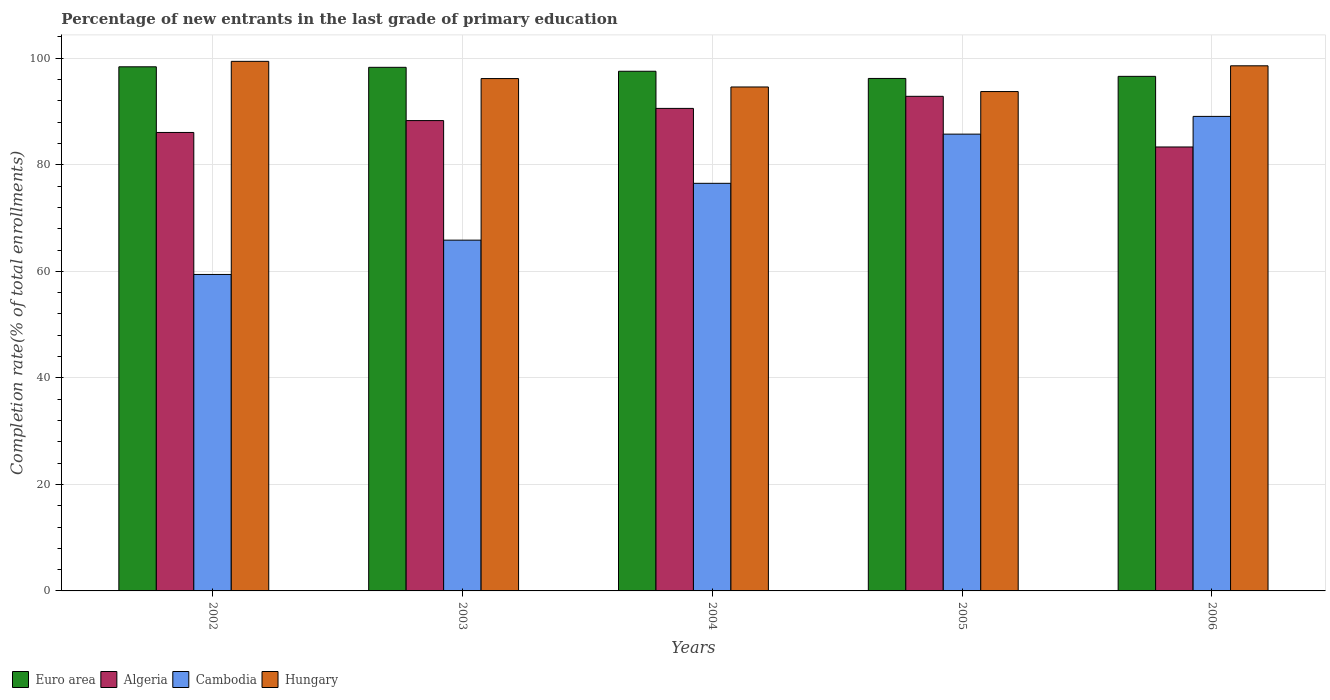How many groups of bars are there?
Ensure brevity in your answer.  5. Are the number of bars per tick equal to the number of legend labels?
Keep it short and to the point. Yes. Are the number of bars on each tick of the X-axis equal?
Your answer should be very brief. Yes. How many bars are there on the 4th tick from the right?
Provide a short and direct response. 4. In how many cases, is the number of bars for a given year not equal to the number of legend labels?
Your answer should be compact. 0. What is the percentage of new entrants in Hungary in 2002?
Provide a short and direct response. 99.42. Across all years, what is the maximum percentage of new entrants in Hungary?
Keep it short and to the point. 99.42. Across all years, what is the minimum percentage of new entrants in Algeria?
Your answer should be compact. 83.35. In which year was the percentage of new entrants in Cambodia maximum?
Your response must be concise. 2006. In which year was the percentage of new entrants in Hungary minimum?
Provide a short and direct response. 2005. What is the total percentage of new entrants in Algeria in the graph?
Keep it short and to the point. 441.18. What is the difference between the percentage of new entrants in Euro area in 2003 and that in 2004?
Offer a very short reply. 0.74. What is the difference between the percentage of new entrants in Cambodia in 2006 and the percentage of new entrants in Algeria in 2002?
Ensure brevity in your answer.  3.01. What is the average percentage of new entrants in Algeria per year?
Keep it short and to the point. 88.24. In the year 2006, what is the difference between the percentage of new entrants in Euro area and percentage of new entrants in Hungary?
Your answer should be compact. -1.98. What is the ratio of the percentage of new entrants in Cambodia in 2002 to that in 2006?
Provide a succinct answer. 0.67. Is the percentage of new entrants in Cambodia in 2003 less than that in 2005?
Keep it short and to the point. Yes. What is the difference between the highest and the second highest percentage of new entrants in Cambodia?
Your answer should be compact. 3.33. What is the difference between the highest and the lowest percentage of new entrants in Hungary?
Offer a very short reply. 5.67. Is it the case that in every year, the sum of the percentage of new entrants in Euro area and percentage of new entrants in Cambodia is greater than the sum of percentage of new entrants in Hungary and percentage of new entrants in Algeria?
Your response must be concise. No. What does the 1st bar from the left in 2005 represents?
Make the answer very short. Euro area. What does the 3rd bar from the right in 2006 represents?
Offer a terse response. Algeria. Are all the bars in the graph horizontal?
Provide a succinct answer. No. How many years are there in the graph?
Your answer should be very brief. 5. What is the difference between two consecutive major ticks on the Y-axis?
Your response must be concise. 20. Are the values on the major ticks of Y-axis written in scientific E-notation?
Your answer should be compact. No. Does the graph contain grids?
Offer a very short reply. Yes. What is the title of the graph?
Provide a short and direct response. Percentage of new entrants in the last grade of primary education. What is the label or title of the X-axis?
Your answer should be compact. Years. What is the label or title of the Y-axis?
Offer a very short reply. Completion rate(% of total enrollments). What is the Completion rate(% of total enrollments) of Euro area in 2002?
Your answer should be compact. 98.4. What is the Completion rate(% of total enrollments) of Algeria in 2002?
Offer a terse response. 86.07. What is the Completion rate(% of total enrollments) of Cambodia in 2002?
Your response must be concise. 59.41. What is the Completion rate(% of total enrollments) in Hungary in 2002?
Provide a short and direct response. 99.42. What is the Completion rate(% of total enrollments) of Euro area in 2003?
Ensure brevity in your answer.  98.3. What is the Completion rate(% of total enrollments) of Algeria in 2003?
Ensure brevity in your answer.  88.3. What is the Completion rate(% of total enrollments) in Cambodia in 2003?
Your answer should be compact. 65.86. What is the Completion rate(% of total enrollments) of Hungary in 2003?
Ensure brevity in your answer.  96.19. What is the Completion rate(% of total enrollments) in Euro area in 2004?
Your answer should be compact. 97.56. What is the Completion rate(% of total enrollments) of Algeria in 2004?
Give a very brief answer. 90.59. What is the Completion rate(% of total enrollments) in Cambodia in 2004?
Provide a succinct answer. 76.53. What is the Completion rate(% of total enrollments) in Hungary in 2004?
Keep it short and to the point. 94.61. What is the Completion rate(% of total enrollments) in Euro area in 2005?
Offer a terse response. 96.21. What is the Completion rate(% of total enrollments) of Algeria in 2005?
Provide a succinct answer. 92.86. What is the Completion rate(% of total enrollments) of Cambodia in 2005?
Provide a succinct answer. 85.76. What is the Completion rate(% of total enrollments) of Hungary in 2005?
Make the answer very short. 93.75. What is the Completion rate(% of total enrollments) of Euro area in 2006?
Your answer should be compact. 96.61. What is the Completion rate(% of total enrollments) in Algeria in 2006?
Offer a very short reply. 83.35. What is the Completion rate(% of total enrollments) in Cambodia in 2006?
Your answer should be very brief. 89.09. What is the Completion rate(% of total enrollments) in Hungary in 2006?
Provide a short and direct response. 98.59. Across all years, what is the maximum Completion rate(% of total enrollments) in Euro area?
Your answer should be compact. 98.4. Across all years, what is the maximum Completion rate(% of total enrollments) of Algeria?
Offer a very short reply. 92.86. Across all years, what is the maximum Completion rate(% of total enrollments) of Cambodia?
Give a very brief answer. 89.09. Across all years, what is the maximum Completion rate(% of total enrollments) in Hungary?
Provide a succinct answer. 99.42. Across all years, what is the minimum Completion rate(% of total enrollments) of Euro area?
Provide a succinct answer. 96.21. Across all years, what is the minimum Completion rate(% of total enrollments) of Algeria?
Give a very brief answer. 83.35. Across all years, what is the minimum Completion rate(% of total enrollments) in Cambodia?
Your answer should be compact. 59.41. Across all years, what is the minimum Completion rate(% of total enrollments) of Hungary?
Offer a terse response. 93.75. What is the total Completion rate(% of total enrollments) of Euro area in the graph?
Provide a succinct answer. 487.09. What is the total Completion rate(% of total enrollments) in Algeria in the graph?
Provide a succinct answer. 441.18. What is the total Completion rate(% of total enrollments) of Cambodia in the graph?
Make the answer very short. 376.64. What is the total Completion rate(% of total enrollments) in Hungary in the graph?
Your answer should be compact. 482.57. What is the difference between the Completion rate(% of total enrollments) in Euro area in 2002 and that in 2003?
Your response must be concise. 0.1. What is the difference between the Completion rate(% of total enrollments) of Algeria in 2002 and that in 2003?
Your answer should be compact. -2.23. What is the difference between the Completion rate(% of total enrollments) of Cambodia in 2002 and that in 2003?
Your response must be concise. -6.44. What is the difference between the Completion rate(% of total enrollments) of Hungary in 2002 and that in 2003?
Give a very brief answer. 3.23. What is the difference between the Completion rate(% of total enrollments) in Euro area in 2002 and that in 2004?
Ensure brevity in your answer.  0.84. What is the difference between the Completion rate(% of total enrollments) of Algeria in 2002 and that in 2004?
Ensure brevity in your answer.  -4.52. What is the difference between the Completion rate(% of total enrollments) of Cambodia in 2002 and that in 2004?
Your response must be concise. -17.11. What is the difference between the Completion rate(% of total enrollments) of Hungary in 2002 and that in 2004?
Your answer should be very brief. 4.81. What is the difference between the Completion rate(% of total enrollments) of Euro area in 2002 and that in 2005?
Your answer should be compact. 2.19. What is the difference between the Completion rate(% of total enrollments) in Algeria in 2002 and that in 2005?
Your response must be concise. -6.78. What is the difference between the Completion rate(% of total enrollments) of Cambodia in 2002 and that in 2005?
Provide a short and direct response. -26.35. What is the difference between the Completion rate(% of total enrollments) of Hungary in 2002 and that in 2005?
Offer a very short reply. 5.67. What is the difference between the Completion rate(% of total enrollments) of Euro area in 2002 and that in 2006?
Provide a succinct answer. 1.79. What is the difference between the Completion rate(% of total enrollments) of Algeria in 2002 and that in 2006?
Ensure brevity in your answer.  2.73. What is the difference between the Completion rate(% of total enrollments) of Cambodia in 2002 and that in 2006?
Your answer should be compact. -29.68. What is the difference between the Completion rate(% of total enrollments) of Hungary in 2002 and that in 2006?
Your response must be concise. 0.84. What is the difference between the Completion rate(% of total enrollments) of Euro area in 2003 and that in 2004?
Ensure brevity in your answer.  0.74. What is the difference between the Completion rate(% of total enrollments) of Algeria in 2003 and that in 2004?
Ensure brevity in your answer.  -2.29. What is the difference between the Completion rate(% of total enrollments) in Cambodia in 2003 and that in 2004?
Keep it short and to the point. -10.67. What is the difference between the Completion rate(% of total enrollments) of Hungary in 2003 and that in 2004?
Make the answer very short. 1.58. What is the difference between the Completion rate(% of total enrollments) of Euro area in 2003 and that in 2005?
Provide a succinct answer. 2.09. What is the difference between the Completion rate(% of total enrollments) in Algeria in 2003 and that in 2005?
Ensure brevity in your answer.  -4.55. What is the difference between the Completion rate(% of total enrollments) of Cambodia in 2003 and that in 2005?
Offer a very short reply. -19.9. What is the difference between the Completion rate(% of total enrollments) of Hungary in 2003 and that in 2005?
Offer a very short reply. 2.44. What is the difference between the Completion rate(% of total enrollments) in Euro area in 2003 and that in 2006?
Provide a succinct answer. 1.69. What is the difference between the Completion rate(% of total enrollments) in Algeria in 2003 and that in 2006?
Provide a succinct answer. 4.96. What is the difference between the Completion rate(% of total enrollments) in Cambodia in 2003 and that in 2006?
Provide a succinct answer. -23.23. What is the difference between the Completion rate(% of total enrollments) of Hungary in 2003 and that in 2006?
Ensure brevity in your answer.  -2.4. What is the difference between the Completion rate(% of total enrollments) in Euro area in 2004 and that in 2005?
Provide a succinct answer. 1.35. What is the difference between the Completion rate(% of total enrollments) of Algeria in 2004 and that in 2005?
Offer a terse response. -2.27. What is the difference between the Completion rate(% of total enrollments) in Cambodia in 2004 and that in 2005?
Give a very brief answer. -9.23. What is the difference between the Completion rate(% of total enrollments) of Hungary in 2004 and that in 2005?
Your answer should be compact. 0.86. What is the difference between the Completion rate(% of total enrollments) in Euro area in 2004 and that in 2006?
Your answer should be compact. 0.96. What is the difference between the Completion rate(% of total enrollments) of Algeria in 2004 and that in 2006?
Your answer should be compact. 7.24. What is the difference between the Completion rate(% of total enrollments) of Cambodia in 2004 and that in 2006?
Provide a short and direct response. -12.56. What is the difference between the Completion rate(% of total enrollments) in Hungary in 2004 and that in 2006?
Ensure brevity in your answer.  -3.98. What is the difference between the Completion rate(% of total enrollments) of Euro area in 2005 and that in 2006?
Provide a short and direct response. -0.39. What is the difference between the Completion rate(% of total enrollments) of Algeria in 2005 and that in 2006?
Make the answer very short. 9.51. What is the difference between the Completion rate(% of total enrollments) of Cambodia in 2005 and that in 2006?
Your answer should be compact. -3.33. What is the difference between the Completion rate(% of total enrollments) in Hungary in 2005 and that in 2006?
Offer a very short reply. -4.83. What is the difference between the Completion rate(% of total enrollments) of Euro area in 2002 and the Completion rate(% of total enrollments) of Algeria in 2003?
Ensure brevity in your answer.  10.1. What is the difference between the Completion rate(% of total enrollments) in Euro area in 2002 and the Completion rate(% of total enrollments) in Cambodia in 2003?
Offer a terse response. 32.55. What is the difference between the Completion rate(% of total enrollments) in Euro area in 2002 and the Completion rate(% of total enrollments) in Hungary in 2003?
Make the answer very short. 2.21. What is the difference between the Completion rate(% of total enrollments) of Algeria in 2002 and the Completion rate(% of total enrollments) of Cambodia in 2003?
Make the answer very short. 20.22. What is the difference between the Completion rate(% of total enrollments) of Algeria in 2002 and the Completion rate(% of total enrollments) of Hungary in 2003?
Your answer should be compact. -10.12. What is the difference between the Completion rate(% of total enrollments) in Cambodia in 2002 and the Completion rate(% of total enrollments) in Hungary in 2003?
Make the answer very short. -36.78. What is the difference between the Completion rate(% of total enrollments) in Euro area in 2002 and the Completion rate(% of total enrollments) in Algeria in 2004?
Your response must be concise. 7.81. What is the difference between the Completion rate(% of total enrollments) of Euro area in 2002 and the Completion rate(% of total enrollments) of Cambodia in 2004?
Give a very brief answer. 21.88. What is the difference between the Completion rate(% of total enrollments) of Euro area in 2002 and the Completion rate(% of total enrollments) of Hungary in 2004?
Offer a very short reply. 3.79. What is the difference between the Completion rate(% of total enrollments) in Algeria in 2002 and the Completion rate(% of total enrollments) in Cambodia in 2004?
Provide a short and direct response. 9.55. What is the difference between the Completion rate(% of total enrollments) of Algeria in 2002 and the Completion rate(% of total enrollments) of Hungary in 2004?
Provide a short and direct response. -8.54. What is the difference between the Completion rate(% of total enrollments) of Cambodia in 2002 and the Completion rate(% of total enrollments) of Hungary in 2004?
Your answer should be very brief. -35.2. What is the difference between the Completion rate(% of total enrollments) of Euro area in 2002 and the Completion rate(% of total enrollments) of Algeria in 2005?
Offer a terse response. 5.54. What is the difference between the Completion rate(% of total enrollments) in Euro area in 2002 and the Completion rate(% of total enrollments) in Cambodia in 2005?
Ensure brevity in your answer.  12.64. What is the difference between the Completion rate(% of total enrollments) of Euro area in 2002 and the Completion rate(% of total enrollments) of Hungary in 2005?
Ensure brevity in your answer.  4.65. What is the difference between the Completion rate(% of total enrollments) of Algeria in 2002 and the Completion rate(% of total enrollments) of Cambodia in 2005?
Keep it short and to the point. 0.32. What is the difference between the Completion rate(% of total enrollments) of Algeria in 2002 and the Completion rate(% of total enrollments) of Hungary in 2005?
Ensure brevity in your answer.  -7.68. What is the difference between the Completion rate(% of total enrollments) in Cambodia in 2002 and the Completion rate(% of total enrollments) in Hungary in 2005?
Give a very brief answer. -34.34. What is the difference between the Completion rate(% of total enrollments) of Euro area in 2002 and the Completion rate(% of total enrollments) of Algeria in 2006?
Your response must be concise. 15.05. What is the difference between the Completion rate(% of total enrollments) of Euro area in 2002 and the Completion rate(% of total enrollments) of Cambodia in 2006?
Offer a very short reply. 9.31. What is the difference between the Completion rate(% of total enrollments) of Euro area in 2002 and the Completion rate(% of total enrollments) of Hungary in 2006?
Offer a very short reply. -0.19. What is the difference between the Completion rate(% of total enrollments) of Algeria in 2002 and the Completion rate(% of total enrollments) of Cambodia in 2006?
Your response must be concise. -3.01. What is the difference between the Completion rate(% of total enrollments) of Algeria in 2002 and the Completion rate(% of total enrollments) of Hungary in 2006?
Give a very brief answer. -12.51. What is the difference between the Completion rate(% of total enrollments) of Cambodia in 2002 and the Completion rate(% of total enrollments) of Hungary in 2006?
Offer a terse response. -39.18. What is the difference between the Completion rate(% of total enrollments) in Euro area in 2003 and the Completion rate(% of total enrollments) in Algeria in 2004?
Your response must be concise. 7.71. What is the difference between the Completion rate(% of total enrollments) in Euro area in 2003 and the Completion rate(% of total enrollments) in Cambodia in 2004?
Your answer should be compact. 21.78. What is the difference between the Completion rate(% of total enrollments) in Euro area in 2003 and the Completion rate(% of total enrollments) in Hungary in 2004?
Offer a terse response. 3.69. What is the difference between the Completion rate(% of total enrollments) of Algeria in 2003 and the Completion rate(% of total enrollments) of Cambodia in 2004?
Offer a terse response. 11.78. What is the difference between the Completion rate(% of total enrollments) in Algeria in 2003 and the Completion rate(% of total enrollments) in Hungary in 2004?
Offer a terse response. -6.31. What is the difference between the Completion rate(% of total enrollments) of Cambodia in 2003 and the Completion rate(% of total enrollments) of Hungary in 2004?
Offer a terse response. -28.76. What is the difference between the Completion rate(% of total enrollments) of Euro area in 2003 and the Completion rate(% of total enrollments) of Algeria in 2005?
Make the answer very short. 5.45. What is the difference between the Completion rate(% of total enrollments) in Euro area in 2003 and the Completion rate(% of total enrollments) in Cambodia in 2005?
Your answer should be compact. 12.54. What is the difference between the Completion rate(% of total enrollments) in Euro area in 2003 and the Completion rate(% of total enrollments) in Hungary in 2005?
Your response must be concise. 4.55. What is the difference between the Completion rate(% of total enrollments) in Algeria in 2003 and the Completion rate(% of total enrollments) in Cambodia in 2005?
Provide a short and direct response. 2.54. What is the difference between the Completion rate(% of total enrollments) in Algeria in 2003 and the Completion rate(% of total enrollments) in Hungary in 2005?
Your response must be concise. -5.45. What is the difference between the Completion rate(% of total enrollments) of Cambodia in 2003 and the Completion rate(% of total enrollments) of Hungary in 2005?
Your answer should be very brief. -27.9. What is the difference between the Completion rate(% of total enrollments) of Euro area in 2003 and the Completion rate(% of total enrollments) of Algeria in 2006?
Your answer should be compact. 14.95. What is the difference between the Completion rate(% of total enrollments) in Euro area in 2003 and the Completion rate(% of total enrollments) in Cambodia in 2006?
Offer a terse response. 9.21. What is the difference between the Completion rate(% of total enrollments) in Euro area in 2003 and the Completion rate(% of total enrollments) in Hungary in 2006?
Your answer should be compact. -0.29. What is the difference between the Completion rate(% of total enrollments) of Algeria in 2003 and the Completion rate(% of total enrollments) of Cambodia in 2006?
Offer a very short reply. -0.79. What is the difference between the Completion rate(% of total enrollments) of Algeria in 2003 and the Completion rate(% of total enrollments) of Hungary in 2006?
Make the answer very short. -10.28. What is the difference between the Completion rate(% of total enrollments) in Cambodia in 2003 and the Completion rate(% of total enrollments) in Hungary in 2006?
Give a very brief answer. -32.73. What is the difference between the Completion rate(% of total enrollments) of Euro area in 2004 and the Completion rate(% of total enrollments) of Algeria in 2005?
Keep it short and to the point. 4.71. What is the difference between the Completion rate(% of total enrollments) in Euro area in 2004 and the Completion rate(% of total enrollments) in Cambodia in 2005?
Your response must be concise. 11.8. What is the difference between the Completion rate(% of total enrollments) of Euro area in 2004 and the Completion rate(% of total enrollments) of Hungary in 2005?
Offer a terse response. 3.81. What is the difference between the Completion rate(% of total enrollments) in Algeria in 2004 and the Completion rate(% of total enrollments) in Cambodia in 2005?
Your answer should be very brief. 4.83. What is the difference between the Completion rate(% of total enrollments) in Algeria in 2004 and the Completion rate(% of total enrollments) in Hungary in 2005?
Your answer should be very brief. -3.16. What is the difference between the Completion rate(% of total enrollments) of Cambodia in 2004 and the Completion rate(% of total enrollments) of Hungary in 2005?
Provide a short and direct response. -17.23. What is the difference between the Completion rate(% of total enrollments) of Euro area in 2004 and the Completion rate(% of total enrollments) of Algeria in 2006?
Ensure brevity in your answer.  14.22. What is the difference between the Completion rate(% of total enrollments) of Euro area in 2004 and the Completion rate(% of total enrollments) of Cambodia in 2006?
Your response must be concise. 8.47. What is the difference between the Completion rate(% of total enrollments) of Euro area in 2004 and the Completion rate(% of total enrollments) of Hungary in 2006?
Keep it short and to the point. -1.02. What is the difference between the Completion rate(% of total enrollments) of Algeria in 2004 and the Completion rate(% of total enrollments) of Cambodia in 2006?
Provide a succinct answer. 1.5. What is the difference between the Completion rate(% of total enrollments) of Algeria in 2004 and the Completion rate(% of total enrollments) of Hungary in 2006?
Offer a very short reply. -8. What is the difference between the Completion rate(% of total enrollments) in Cambodia in 2004 and the Completion rate(% of total enrollments) in Hungary in 2006?
Your response must be concise. -22.06. What is the difference between the Completion rate(% of total enrollments) in Euro area in 2005 and the Completion rate(% of total enrollments) in Algeria in 2006?
Make the answer very short. 12.87. What is the difference between the Completion rate(% of total enrollments) of Euro area in 2005 and the Completion rate(% of total enrollments) of Cambodia in 2006?
Offer a very short reply. 7.13. What is the difference between the Completion rate(% of total enrollments) of Euro area in 2005 and the Completion rate(% of total enrollments) of Hungary in 2006?
Offer a terse response. -2.37. What is the difference between the Completion rate(% of total enrollments) of Algeria in 2005 and the Completion rate(% of total enrollments) of Cambodia in 2006?
Provide a short and direct response. 3.77. What is the difference between the Completion rate(% of total enrollments) in Algeria in 2005 and the Completion rate(% of total enrollments) in Hungary in 2006?
Your response must be concise. -5.73. What is the difference between the Completion rate(% of total enrollments) of Cambodia in 2005 and the Completion rate(% of total enrollments) of Hungary in 2006?
Give a very brief answer. -12.83. What is the average Completion rate(% of total enrollments) in Euro area per year?
Provide a short and direct response. 97.42. What is the average Completion rate(% of total enrollments) of Algeria per year?
Provide a succinct answer. 88.24. What is the average Completion rate(% of total enrollments) of Cambodia per year?
Offer a terse response. 75.33. What is the average Completion rate(% of total enrollments) of Hungary per year?
Give a very brief answer. 96.51. In the year 2002, what is the difference between the Completion rate(% of total enrollments) in Euro area and Completion rate(% of total enrollments) in Algeria?
Ensure brevity in your answer.  12.33. In the year 2002, what is the difference between the Completion rate(% of total enrollments) in Euro area and Completion rate(% of total enrollments) in Cambodia?
Keep it short and to the point. 38.99. In the year 2002, what is the difference between the Completion rate(% of total enrollments) of Euro area and Completion rate(% of total enrollments) of Hungary?
Your answer should be compact. -1.02. In the year 2002, what is the difference between the Completion rate(% of total enrollments) in Algeria and Completion rate(% of total enrollments) in Cambodia?
Provide a succinct answer. 26.66. In the year 2002, what is the difference between the Completion rate(% of total enrollments) in Algeria and Completion rate(% of total enrollments) in Hungary?
Ensure brevity in your answer.  -13.35. In the year 2002, what is the difference between the Completion rate(% of total enrollments) in Cambodia and Completion rate(% of total enrollments) in Hungary?
Ensure brevity in your answer.  -40.01. In the year 2003, what is the difference between the Completion rate(% of total enrollments) of Euro area and Completion rate(% of total enrollments) of Algeria?
Give a very brief answer. 10. In the year 2003, what is the difference between the Completion rate(% of total enrollments) in Euro area and Completion rate(% of total enrollments) in Cambodia?
Your response must be concise. 32.45. In the year 2003, what is the difference between the Completion rate(% of total enrollments) of Euro area and Completion rate(% of total enrollments) of Hungary?
Provide a short and direct response. 2.11. In the year 2003, what is the difference between the Completion rate(% of total enrollments) of Algeria and Completion rate(% of total enrollments) of Cambodia?
Offer a very short reply. 22.45. In the year 2003, what is the difference between the Completion rate(% of total enrollments) in Algeria and Completion rate(% of total enrollments) in Hungary?
Your response must be concise. -7.89. In the year 2003, what is the difference between the Completion rate(% of total enrollments) of Cambodia and Completion rate(% of total enrollments) of Hungary?
Provide a succinct answer. -30.33. In the year 2004, what is the difference between the Completion rate(% of total enrollments) in Euro area and Completion rate(% of total enrollments) in Algeria?
Make the answer very short. 6.97. In the year 2004, what is the difference between the Completion rate(% of total enrollments) in Euro area and Completion rate(% of total enrollments) in Cambodia?
Your answer should be compact. 21.04. In the year 2004, what is the difference between the Completion rate(% of total enrollments) in Euro area and Completion rate(% of total enrollments) in Hungary?
Offer a very short reply. 2.95. In the year 2004, what is the difference between the Completion rate(% of total enrollments) in Algeria and Completion rate(% of total enrollments) in Cambodia?
Provide a short and direct response. 14.06. In the year 2004, what is the difference between the Completion rate(% of total enrollments) in Algeria and Completion rate(% of total enrollments) in Hungary?
Ensure brevity in your answer.  -4.02. In the year 2004, what is the difference between the Completion rate(% of total enrollments) of Cambodia and Completion rate(% of total enrollments) of Hungary?
Provide a short and direct response. -18.09. In the year 2005, what is the difference between the Completion rate(% of total enrollments) of Euro area and Completion rate(% of total enrollments) of Algeria?
Offer a very short reply. 3.36. In the year 2005, what is the difference between the Completion rate(% of total enrollments) of Euro area and Completion rate(% of total enrollments) of Cambodia?
Offer a very short reply. 10.46. In the year 2005, what is the difference between the Completion rate(% of total enrollments) of Euro area and Completion rate(% of total enrollments) of Hungary?
Keep it short and to the point. 2.46. In the year 2005, what is the difference between the Completion rate(% of total enrollments) in Algeria and Completion rate(% of total enrollments) in Cambodia?
Offer a very short reply. 7.1. In the year 2005, what is the difference between the Completion rate(% of total enrollments) of Algeria and Completion rate(% of total enrollments) of Hungary?
Your answer should be very brief. -0.9. In the year 2005, what is the difference between the Completion rate(% of total enrollments) in Cambodia and Completion rate(% of total enrollments) in Hungary?
Offer a terse response. -7.99. In the year 2006, what is the difference between the Completion rate(% of total enrollments) in Euro area and Completion rate(% of total enrollments) in Algeria?
Your answer should be compact. 13.26. In the year 2006, what is the difference between the Completion rate(% of total enrollments) in Euro area and Completion rate(% of total enrollments) in Cambodia?
Provide a short and direct response. 7.52. In the year 2006, what is the difference between the Completion rate(% of total enrollments) of Euro area and Completion rate(% of total enrollments) of Hungary?
Your answer should be compact. -1.98. In the year 2006, what is the difference between the Completion rate(% of total enrollments) of Algeria and Completion rate(% of total enrollments) of Cambodia?
Keep it short and to the point. -5.74. In the year 2006, what is the difference between the Completion rate(% of total enrollments) of Algeria and Completion rate(% of total enrollments) of Hungary?
Offer a very short reply. -15.24. In the year 2006, what is the difference between the Completion rate(% of total enrollments) in Cambodia and Completion rate(% of total enrollments) in Hungary?
Your answer should be very brief. -9.5. What is the ratio of the Completion rate(% of total enrollments) in Algeria in 2002 to that in 2003?
Your answer should be very brief. 0.97. What is the ratio of the Completion rate(% of total enrollments) in Cambodia in 2002 to that in 2003?
Your answer should be compact. 0.9. What is the ratio of the Completion rate(% of total enrollments) in Hungary in 2002 to that in 2003?
Your answer should be compact. 1.03. What is the ratio of the Completion rate(% of total enrollments) of Euro area in 2002 to that in 2004?
Ensure brevity in your answer.  1.01. What is the ratio of the Completion rate(% of total enrollments) in Algeria in 2002 to that in 2004?
Provide a short and direct response. 0.95. What is the ratio of the Completion rate(% of total enrollments) in Cambodia in 2002 to that in 2004?
Make the answer very short. 0.78. What is the ratio of the Completion rate(% of total enrollments) in Hungary in 2002 to that in 2004?
Make the answer very short. 1.05. What is the ratio of the Completion rate(% of total enrollments) of Euro area in 2002 to that in 2005?
Give a very brief answer. 1.02. What is the ratio of the Completion rate(% of total enrollments) of Algeria in 2002 to that in 2005?
Your response must be concise. 0.93. What is the ratio of the Completion rate(% of total enrollments) of Cambodia in 2002 to that in 2005?
Give a very brief answer. 0.69. What is the ratio of the Completion rate(% of total enrollments) in Hungary in 2002 to that in 2005?
Provide a short and direct response. 1.06. What is the ratio of the Completion rate(% of total enrollments) in Euro area in 2002 to that in 2006?
Your answer should be very brief. 1.02. What is the ratio of the Completion rate(% of total enrollments) of Algeria in 2002 to that in 2006?
Keep it short and to the point. 1.03. What is the ratio of the Completion rate(% of total enrollments) in Cambodia in 2002 to that in 2006?
Provide a short and direct response. 0.67. What is the ratio of the Completion rate(% of total enrollments) of Hungary in 2002 to that in 2006?
Your response must be concise. 1.01. What is the ratio of the Completion rate(% of total enrollments) in Euro area in 2003 to that in 2004?
Your answer should be very brief. 1.01. What is the ratio of the Completion rate(% of total enrollments) of Algeria in 2003 to that in 2004?
Provide a succinct answer. 0.97. What is the ratio of the Completion rate(% of total enrollments) in Cambodia in 2003 to that in 2004?
Ensure brevity in your answer.  0.86. What is the ratio of the Completion rate(% of total enrollments) in Hungary in 2003 to that in 2004?
Provide a short and direct response. 1.02. What is the ratio of the Completion rate(% of total enrollments) of Euro area in 2003 to that in 2005?
Keep it short and to the point. 1.02. What is the ratio of the Completion rate(% of total enrollments) in Algeria in 2003 to that in 2005?
Keep it short and to the point. 0.95. What is the ratio of the Completion rate(% of total enrollments) in Cambodia in 2003 to that in 2005?
Provide a short and direct response. 0.77. What is the ratio of the Completion rate(% of total enrollments) of Euro area in 2003 to that in 2006?
Make the answer very short. 1.02. What is the ratio of the Completion rate(% of total enrollments) in Algeria in 2003 to that in 2006?
Your answer should be very brief. 1.06. What is the ratio of the Completion rate(% of total enrollments) in Cambodia in 2003 to that in 2006?
Provide a short and direct response. 0.74. What is the ratio of the Completion rate(% of total enrollments) of Hungary in 2003 to that in 2006?
Give a very brief answer. 0.98. What is the ratio of the Completion rate(% of total enrollments) in Euro area in 2004 to that in 2005?
Your response must be concise. 1.01. What is the ratio of the Completion rate(% of total enrollments) of Algeria in 2004 to that in 2005?
Your answer should be very brief. 0.98. What is the ratio of the Completion rate(% of total enrollments) in Cambodia in 2004 to that in 2005?
Provide a succinct answer. 0.89. What is the ratio of the Completion rate(% of total enrollments) of Hungary in 2004 to that in 2005?
Offer a terse response. 1.01. What is the ratio of the Completion rate(% of total enrollments) in Euro area in 2004 to that in 2006?
Offer a very short reply. 1.01. What is the ratio of the Completion rate(% of total enrollments) of Algeria in 2004 to that in 2006?
Your response must be concise. 1.09. What is the ratio of the Completion rate(% of total enrollments) of Cambodia in 2004 to that in 2006?
Offer a terse response. 0.86. What is the ratio of the Completion rate(% of total enrollments) in Hungary in 2004 to that in 2006?
Your answer should be very brief. 0.96. What is the ratio of the Completion rate(% of total enrollments) in Euro area in 2005 to that in 2006?
Your answer should be compact. 1. What is the ratio of the Completion rate(% of total enrollments) in Algeria in 2005 to that in 2006?
Provide a short and direct response. 1.11. What is the ratio of the Completion rate(% of total enrollments) in Cambodia in 2005 to that in 2006?
Your response must be concise. 0.96. What is the ratio of the Completion rate(% of total enrollments) in Hungary in 2005 to that in 2006?
Your response must be concise. 0.95. What is the difference between the highest and the second highest Completion rate(% of total enrollments) of Euro area?
Provide a succinct answer. 0.1. What is the difference between the highest and the second highest Completion rate(% of total enrollments) in Algeria?
Your answer should be compact. 2.27. What is the difference between the highest and the second highest Completion rate(% of total enrollments) of Cambodia?
Your response must be concise. 3.33. What is the difference between the highest and the second highest Completion rate(% of total enrollments) in Hungary?
Keep it short and to the point. 0.84. What is the difference between the highest and the lowest Completion rate(% of total enrollments) in Euro area?
Your response must be concise. 2.19. What is the difference between the highest and the lowest Completion rate(% of total enrollments) of Algeria?
Offer a terse response. 9.51. What is the difference between the highest and the lowest Completion rate(% of total enrollments) of Cambodia?
Ensure brevity in your answer.  29.68. What is the difference between the highest and the lowest Completion rate(% of total enrollments) in Hungary?
Make the answer very short. 5.67. 